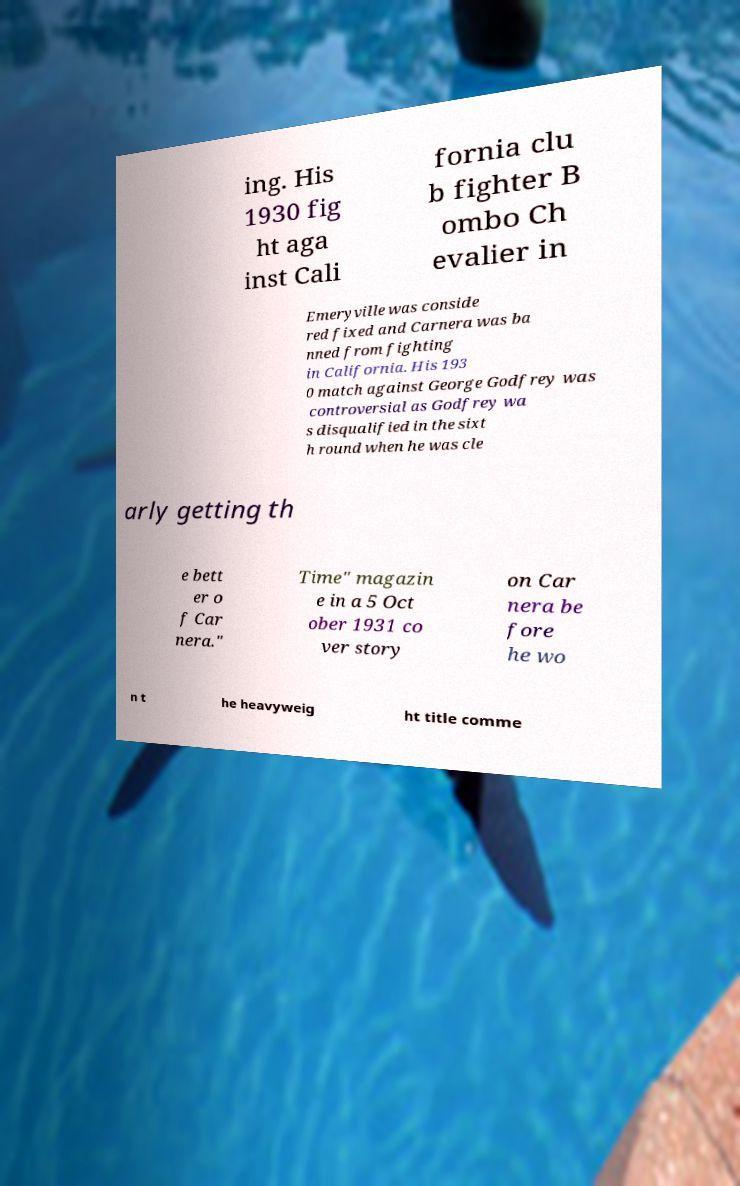Can you read and provide the text displayed in the image?This photo seems to have some interesting text. Can you extract and type it out for me? ing. His 1930 fig ht aga inst Cali fornia clu b fighter B ombo Ch evalier in Emeryville was conside red fixed and Carnera was ba nned from fighting in California. His 193 0 match against George Godfrey was controversial as Godfrey wa s disqualified in the sixt h round when he was cle arly getting th e bett er o f Car nera." Time" magazin e in a 5 Oct ober 1931 co ver story on Car nera be fore he wo n t he heavyweig ht title comme 